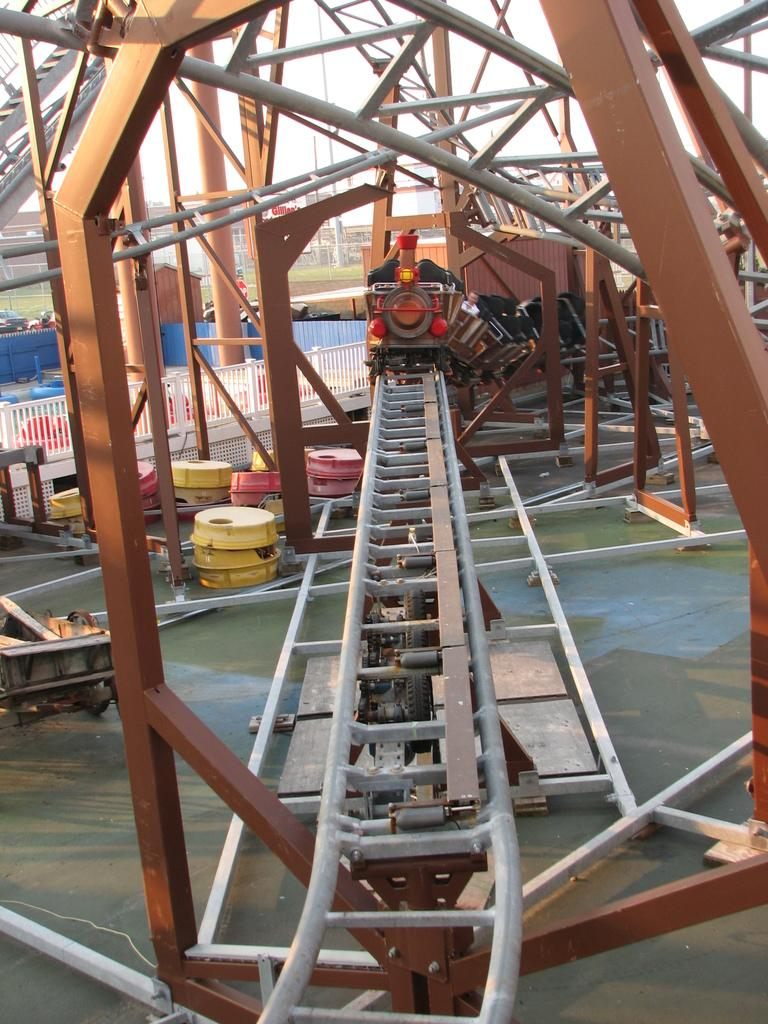What mode of transportation can be seen in the image? There is a train on a railway track in the image. What type of objects are present near the train? There are boxes and rods in the image. What type of barrier can be seen in the image? There are fences in the image. What type of structure can be seen in the image? There is a shed in the image. What type of vehicles are present in the image? There are vehicles in the image. What type of vegetation is present in the image? There is grass in the image. What type of structures can be seen in the background of the image? There are buildings in the image. What is visible in the background of the image? The sky is visible in the background of the image. What type of clouds can be seen in the image? There are no clouds visible in the image; only the sky is visible in the background. 